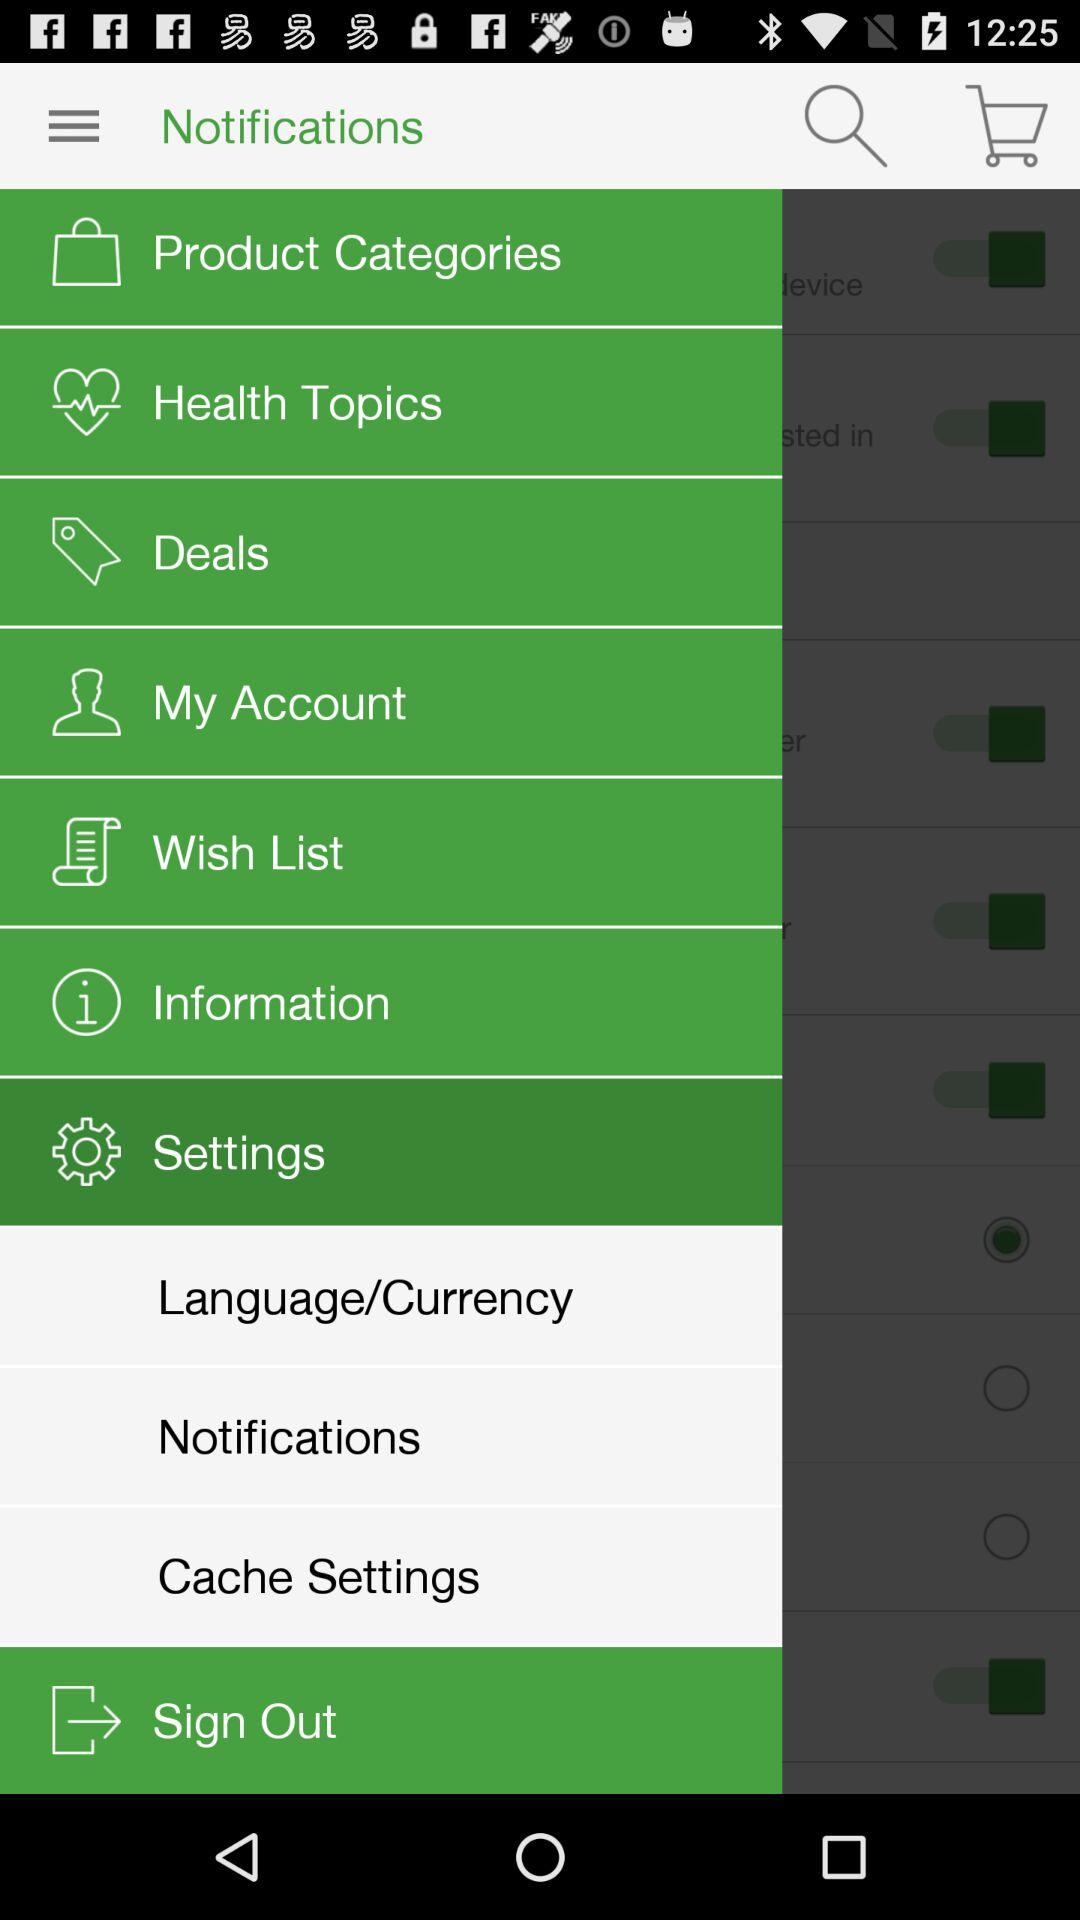What's the selected menu option? The selected menu option is Settings. 